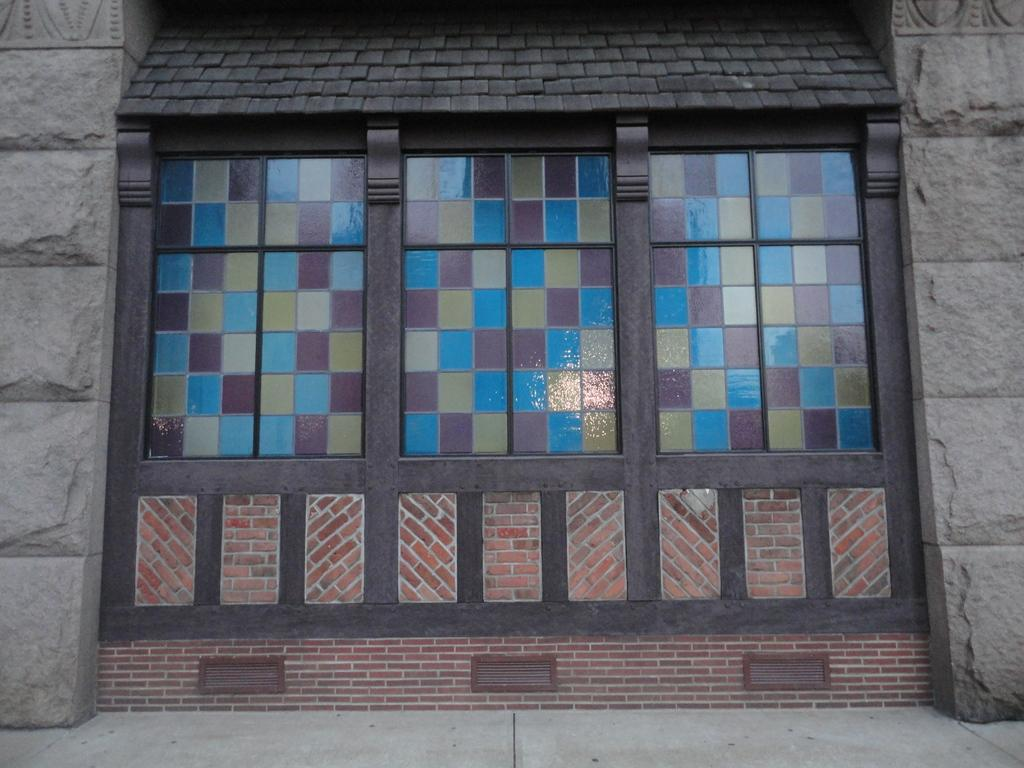What is present on a surface in the image? There is a window in the image. Where is the window located? The window is on a wall. What is unique about the appearance of the window? The window is painted with multiple colors. Can you see any ducks swimming in the harbor in the image? There is no harbor or ducks present in the image; it features a window painted with multiple colors. 